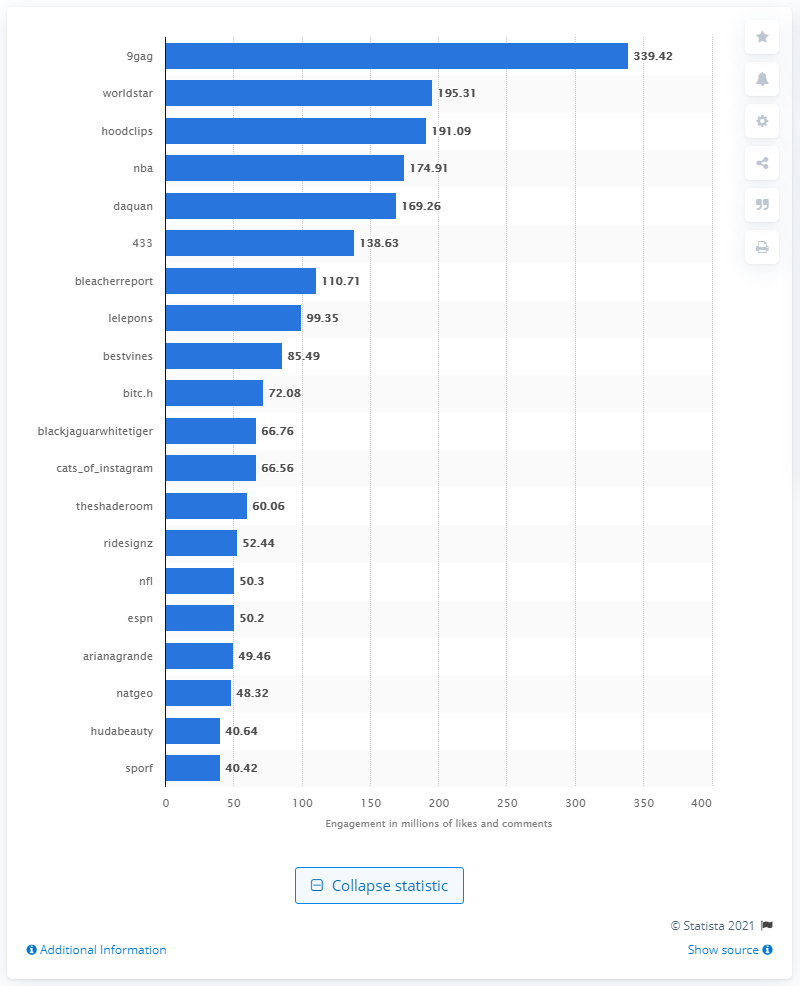Highlight a few significant elements in this photo. The account with the highest volume of user engagement with its video content was 9gag. 9gag received a total of 339.42 likes and comments. 